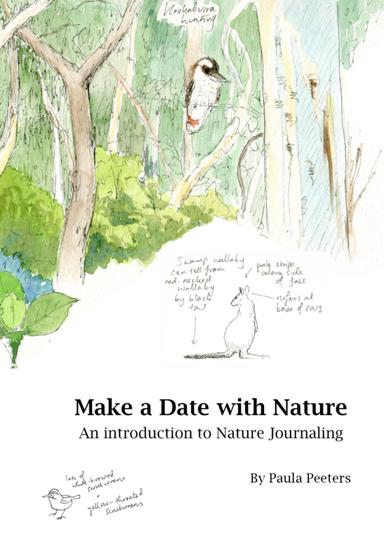What specific techniques are suggested in the book for nature journaling? The book suggests several techniques for nature journaling, including detailed sketching of local flora and fauna, writing observational notes, and painting landscapes or natural scenes. These techniques aim to enhance the observer's ability to see and appreciate finer details of the environment. Can you describe one of the sketches from the cover of the book? One of the sketches on the book’s cover depicts a serene woodland scene with a cockatoo perched in a eucalyptus tree. The sketch is lively and expressive, capturing the essence of a quiet moment in nature, using soft watercolors and fine lines to illustrate the tranquility of the setting. 